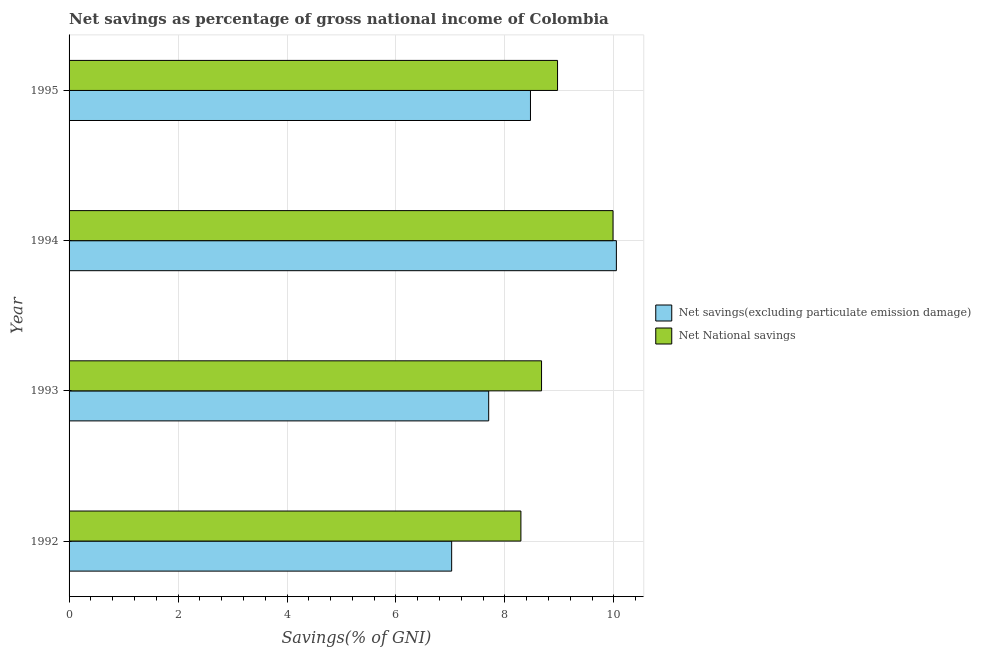How many different coloured bars are there?
Make the answer very short. 2. How many groups of bars are there?
Offer a very short reply. 4. Are the number of bars per tick equal to the number of legend labels?
Your answer should be compact. Yes. How many bars are there on the 2nd tick from the top?
Provide a short and direct response. 2. What is the label of the 4th group of bars from the top?
Offer a terse response. 1992. What is the net national savings in 1992?
Your answer should be very brief. 8.29. Across all years, what is the maximum net national savings?
Your answer should be very brief. 9.98. Across all years, what is the minimum net national savings?
Your answer should be compact. 8.29. In which year was the net national savings maximum?
Provide a short and direct response. 1994. What is the total net national savings in the graph?
Give a very brief answer. 35.91. What is the difference between the net national savings in 1994 and that in 1995?
Offer a terse response. 1.02. What is the difference between the net savings(excluding particulate emission damage) in 1994 and the net national savings in 1993?
Provide a succinct answer. 1.37. What is the average net savings(excluding particulate emission damage) per year?
Give a very brief answer. 8.31. In the year 1994, what is the difference between the net national savings and net savings(excluding particulate emission damage)?
Keep it short and to the point. -0.06. In how many years, is the net savings(excluding particulate emission damage) greater than 8.8 %?
Make the answer very short. 1. What is the ratio of the net national savings in 1992 to that in 1994?
Give a very brief answer. 0.83. Is the net savings(excluding particulate emission damage) in 1993 less than that in 1994?
Provide a succinct answer. Yes. What is the difference between the highest and the second highest net savings(excluding particulate emission damage)?
Your response must be concise. 1.58. What is the difference between the highest and the lowest net national savings?
Your response must be concise. 1.69. In how many years, is the net savings(excluding particulate emission damage) greater than the average net savings(excluding particulate emission damage) taken over all years?
Your answer should be very brief. 2. Is the sum of the net savings(excluding particulate emission damage) in 1993 and 1995 greater than the maximum net national savings across all years?
Your answer should be compact. Yes. What does the 1st bar from the top in 1995 represents?
Your answer should be compact. Net National savings. What does the 2nd bar from the bottom in 1992 represents?
Provide a short and direct response. Net National savings. How many years are there in the graph?
Ensure brevity in your answer.  4. What is the difference between two consecutive major ticks on the X-axis?
Your answer should be very brief. 2. Are the values on the major ticks of X-axis written in scientific E-notation?
Provide a short and direct response. No. Does the graph contain any zero values?
Your answer should be compact. No. Does the graph contain grids?
Offer a very short reply. Yes. What is the title of the graph?
Offer a very short reply. Net savings as percentage of gross national income of Colombia. What is the label or title of the X-axis?
Provide a short and direct response. Savings(% of GNI). What is the Savings(% of GNI) of Net savings(excluding particulate emission damage) in 1992?
Make the answer very short. 7.02. What is the Savings(% of GNI) in Net National savings in 1992?
Your answer should be compact. 8.29. What is the Savings(% of GNI) of Net savings(excluding particulate emission damage) in 1993?
Your response must be concise. 7.7. What is the Savings(% of GNI) of Net National savings in 1993?
Your response must be concise. 8.67. What is the Savings(% of GNI) of Net savings(excluding particulate emission damage) in 1994?
Provide a short and direct response. 10.05. What is the Savings(% of GNI) of Net National savings in 1994?
Your answer should be compact. 9.98. What is the Savings(% of GNI) of Net savings(excluding particulate emission damage) in 1995?
Offer a very short reply. 8.47. What is the Savings(% of GNI) in Net National savings in 1995?
Make the answer very short. 8.97. Across all years, what is the maximum Savings(% of GNI) in Net savings(excluding particulate emission damage)?
Make the answer very short. 10.05. Across all years, what is the maximum Savings(% of GNI) of Net National savings?
Provide a short and direct response. 9.98. Across all years, what is the minimum Savings(% of GNI) of Net savings(excluding particulate emission damage)?
Offer a terse response. 7.02. Across all years, what is the minimum Savings(% of GNI) of Net National savings?
Offer a terse response. 8.29. What is the total Savings(% of GNI) in Net savings(excluding particulate emission damage) in the graph?
Give a very brief answer. 33.24. What is the total Savings(% of GNI) of Net National savings in the graph?
Your response must be concise. 35.91. What is the difference between the Savings(% of GNI) of Net savings(excluding particulate emission damage) in 1992 and that in 1993?
Offer a terse response. -0.68. What is the difference between the Savings(% of GNI) in Net National savings in 1992 and that in 1993?
Keep it short and to the point. -0.38. What is the difference between the Savings(% of GNI) of Net savings(excluding particulate emission damage) in 1992 and that in 1994?
Provide a short and direct response. -3.02. What is the difference between the Savings(% of GNI) in Net National savings in 1992 and that in 1994?
Give a very brief answer. -1.69. What is the difference between the Savings(% of GNI) in Net savings(excluding particulate emission damage) in 1992 and that in 1995?
Offer a very short reply. -1.45. What is the difference between the Savings(% of GNI) of Net National savings in 1992 and that in 1995?
Make the answer very short. -0.67. What is the difference between the Savings(% of GNI) of Net savings(excluding particulate emission damage) in 1993 and that in 1994?
Ensure brevity in your answer.  -2.34. What is the difference between the Savings(% of GNI) of Net National savings in 1993 and that in 1994?
Your answer should be compact. -1.31. What is the difference between the Savings(% of GNI) of Net savings(excluding particulate emission damage) in 1993 and that in 1995?
Your answer should be compact. -0.77. What is the difference between the Savings(% of GNI) in Net National savings in 1993 and that in 1995?
Provide a short and direct response. -0.29. What is the difference between the Savings(% of GNI) in Net savings(excluding particulate emission damage) in 1994 and that in 1995?
Ensure brevity in your answer.  1.58. What is the difference between the Savings(% of GNI) of Net National savings in 1994 and that in 1995?
Offer a very short reply. 1.02. What is the difference between the Savings(% of GNI) in Net savings(excluding particulate emission damage) in 1992 and the Savings(% of GNI) in Net National savings in 1993?
Offer a terse response. -1.65. What is the difference between the Savings(% of GNI) of Net savings(excluding particulate emission damage) in 1992 and the Savings(% of GNI) of Net National savings in 1994?
Give a very brief answer. -2.96. What is the difference between the Savings(% of GNI) in Net savings(excluding particulate emission damage) in 1992 and the Savings(% of GNI) in Net National savings in 1995?
Offer a terse response. -1.94. What is the difference between the Savings(% of GNI) of Net savings(excluding particulate emission damage) in 1993 and the Savings(% of GNI) of Net National savings in 1994?
Provide a succinct answer. -2.28. What is the difference between the Savings(% of GNI) in Net savings(excluding particulate emission damage) in 1993 and the Savings(% of GNI) in Net National savings in 1995?
Provide a succinct answer. -1.26. What is the difference between the Savings(% of GNI) of Net savings(excluding particulate emission damage) in 1994 and the Savings(% of GNI) of Net National savings in 1995?
Make the answer very short. 1.08. What is the average Savings(% of GNI) of Net savings(excluding particulate emission damage) per year?
Your answer should be compact. 8.31. What is the average Savings(% of GNI) of Net National savings per year?
Your answer should be very brief. 8.98. In the year 1992, what is the difference between the Savings(% of GNI) in Net savings(excluding particulate emission damage) and Savings(% of GNI) in Net National savings?
Keep it short and to the point. -1.27. In the year 1993, what is the difference between the Savings(% of GNI) of Net savings(excluding particulate emission damage) and Savings(% of GNI) of Net National savings?
Provide a succinct answer. -0.97. In the year 1994, what is the difference between the Savings(% of GNI) of Net savings(excluding particulate emission damage) and Savings(% of GNI) of Net National savings?
Keep it short and to the point. 0.06. In the year 1995, what is the difference between the Savings(% of GNI) in Net savings(excluding particulate emission damage) and Savings(% of GNI) in Net National savings?
Make the answer very short. -0.5. What is the ratio of the Savings(% of GNI) in Net savings(excluding particulate emission damage) in 1992 to that in 1993?
Your answer should be very brief. 0.91. What is the ratio of the Savings(% of GNI) in Net National savings in 1992 to that in 1993?
Your response must be concise. 0.96. What is the ratio of the Savings(% of GNI) in Net savings(excluding particulate emission damage) in 1992 to that in 1994?
Provide a succinct answer. 0.7. What is the ratio of the Savings(% of GNI) of Net National savings in 1992 to that in 1994?
Provide a short and direct response. 0.83. What is the ratio of the Savings(% of GNI) in Net savings(excluding particulate emission damage) in 1992 to that in 1995?
Offer a very short reply. 0.83. What is the ratio of the Savings(% of GNI) of Net National savings in 1992 to that in 1995?
Keep it short and to the point. 0.93. What is the ratio of the Savings(% of GNI) in Net savings(excluding particulate emission damage) in 1993 to that in 1994?
Provide a succinct answer. 0.77. What is the ratio of the Savings(% of GNI) in Net National savings in 1993 to that in 1994?
Your answer should be compact. 0.87. What is the ratio of the Savings(% of GNI) of Net savings(excluding particulate emission damage) in 1993 to that in 1995?
Offer a very short reply. 0.91. What is the ratio of the Savings(% of GNI) in Net National savings in 1993 to that in 1995?
Provide a succinct answer. 0.97. What is the ratio of the Savings(% of GNI) of Net savings(excluding particulate emission damage) in 1994 to that in 1995?
Your answer should be compact. 1.19. What is the ratio of the Savings(% of GNI) in Net National savings in 1994 to that in 1995?
Make the answer very short. 1.11. What is the difference between the highest and the second highest Savings(% of GNI) in Net savings(excluding particulate emission damage)?
Your answer should be compact. 1.58. What is the difference between the highest and the second highest Savings(% of GNI) of Net National savings?
Keep it short and to the point. 1.02. What is the difference between the highest and the lowest Savings(% of GNI) in Net savings(excluding particulate emission damage)?
Your response must be concise. 3.02. What is the difference between the highest and the lowest Savings(% of GNI) of Net National savings?
Make the answer very short. 1.69. 